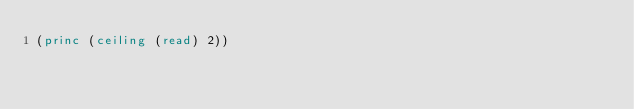<code> <loc_0><loc_0><loc_500><loc_500><_Lisp_>(princ (ceiling (read) 2))</code> 